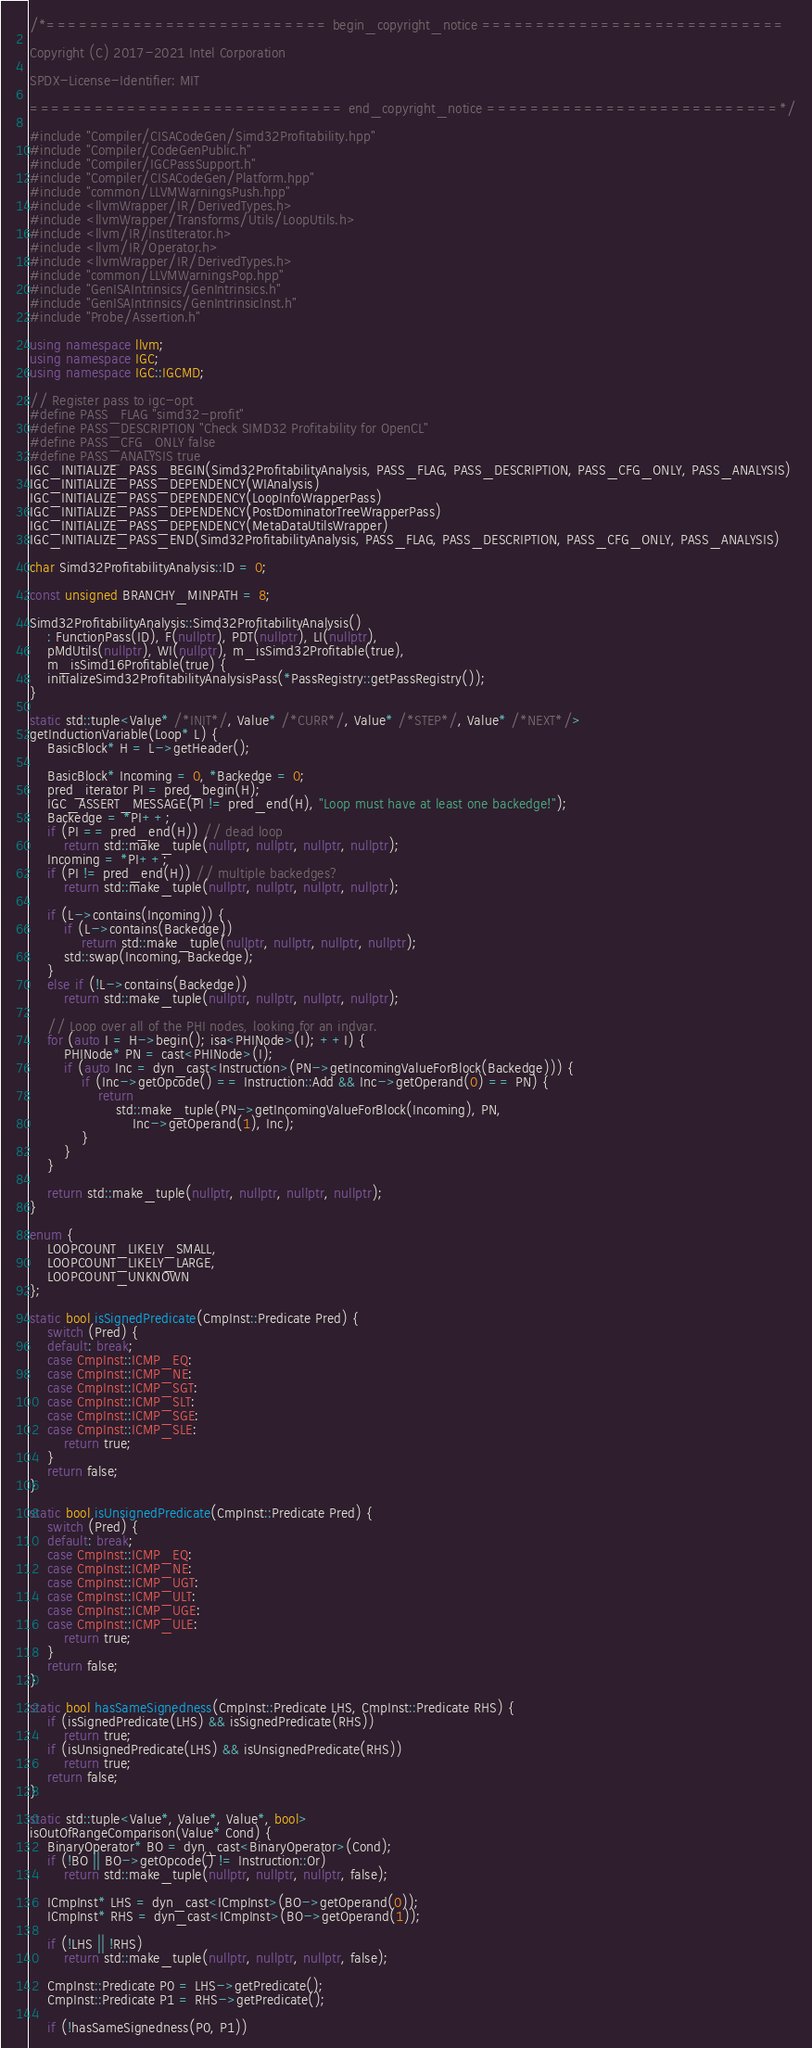Convert code to text. <code><loc_0><loc_0><loc_500><loc_500><_C++_>/*========================== begin_copyright_notice ============================

Copyright (C) 2017-2021 Intel Corporation

SPDX-License-Identifier: MIT

============================= end_copyright_notice ===========================*/

#include "Compiler/CISACodeGen/Simd32Profitability.hpp"
#include "Compiler/CodeGenPublic.h"
#include "Compiler/IGCPassSupport.h"
#include "Compiler/CISACodeGen/Platform.hpp"
#include "common/LLVMWarningsPush.hpp"
#include <llvmWrapper/IR/DerivedTypes.h>
#include <llvmWrapper/Transforms/Utils/LoopUtils.h>
#include <llvm/IR/InstIterator.h>
#include <llvm/IR/Operator.h>
#include <llvmWrapper/IR/DerivedTypes.h>
#include "common/LLVMWarningsPop.hpp"
#include "GenISAIntrinsics/GenIntrinsics.h"
#include "GenISAIntrinsics/GenIntrinsicInst.h"
#include "Probe/Assertion.h"

using namespace llvm;
using namespace IGC;
using namespace IGC::IGCMD;

// Register pass to igc-opt
#define PASS_FLAG "simd32-profit"
#define PASS_DESCRIPTION "Check SIMD32 Profitability for OpenCL"
#define PASS_CFG_ONLY false
#define PASS_ANALYSIS true
IGC_INITIALIZE_PASS_BEGIN(Simd32ProfitabilityAnalysis, PASS_FLAG, PASS_DESCRIPTION, PASS_CFG_ONLY, PASS_ANALYSIS)
IGC_INITIALIZE_PASS_DEPENDENCY(WIAnalysis)
IGC_INITIALIZE_PASS_DEPENDENCY(LoopInfoWrapperPass)
IGC_INITIALIZE_PASS_DEPENDENCY(PostDominatorTreeWrapperPass)
IGC_INITIALIZE_PASS_DEPENDENCY(MetaDataUtilsWrapper)
IGC_INITIALIZE_PASS_END(Simd32ProfitabilityAnalysis, PASS_FLAG, PASS_DESCRIPTION, PASS_CFG_ONLY, PASS_ANALYSIS)

char Simd32ProfitabilityAnalysis::ID = 0;

const unsigned BRANCHY_MINPATH = 8;

Simd32ProfitabilityAnalysis::Simd32ProfitabilityAnalysis()
    : FunctionPass(ID), F(nullptr), PDT(nullptr), LI(nullptr),
    pMdUtils(nullptr), WI(nullptr), m_isSimd32Profitable(true),
    m_isSimd16Profitable(true) {
    initializeSimd32ProfitabilityAnalysisPass(*PassRegistry::getPassRegistry());
}

static std::tuple<Value* /*INIT*/, Value* /*CURR*/, Value* /*STEP*/, Value* /*NEXT*/>
getInductionVariable(Loop* L) {
    BasicBlock* H = L->getHeader();

    BasicBlock* Incoming = 0, *Backedge = 0;
    pred_iterator PI = pred_begin(H);
    IGC_ASSERT_MESSAGE(PI != pred_end(H), "Loop must have at least one backedge!");
    Backedge = *PI++;
    if (PI == pred_end(H)) // dead loop
        return std::make_tuple(nullptr, nullptr, nullptr, nullptr);
    Incoming = *PI++;
    if (PI != pred_end(H)) // multiple backedges?
        return std::make_tuple(nullptr, nullptr, nullptr, nullptr);

    if (L->contains(Incoming)) {
        if (L->contains(Backedge))
            return std::make_tuple(nullptr, nullptr, nullptr, nullptr);
        std::swap(Incoming, Backedge);
    }
    else if (!L->contains(Backedge))
        return std::make_tuple(nullptr, nullptr, nullptr, nullptr);

    // Loop over all of the PHI nodes, looking for an indvar.
    for (auto I = H->begin(); isa<PHINode>(I); ++I) {
        PHINode* PN = cast<PHINode>(I);
        if (auto Inc = dyn_cast<Instruction>(PN->getIncomingValueForBlock(Backedge))) {
            if (Inc->getOpcode() == Instruction::Add && Inc->getOperand(0) == PN) {
                return
                    std::make_tuple(PN->getIncomingValueForBlock(Incoming), PN,
                        Inc->getOperand(1), Inc);
            }
        }
    }

    return std::make_tuple(nullptr, nullptr, nullptr, nullptr);
}

enum {
    LOOPCOUNT_LIKELY_SMALL,
    LOOPCOUNT_LIKELY_LARGE,
    LOOPCOUNT_UNKNOWN
};

static bool isSignedPredicate(CmpInst::Predicate Pred) {
    switch (Pred) {
    default: break;
    case CmpInst::ICMP_EQ:
    case CmpInst::ICMP_NE:
    case CmpInst::ICMP_SGT:
    case CmpInst::ICMP_SLT:
    case CmpInst::ICMP_SGE:
    case CmpInst::ICMP_SLE:
        return true;
    }
    return false;
}

static bool isUnsignedPredicate(CmpInst::Predicate Pred) {
    switch (Pred) {
    default: break;
    case CmpInst::ICMP_EQ:
    case CmpInst::ICMP_NE:
    case CmpInst::ICMP_UGT:
    case CmpInst::ICMP_ULT:
    case CmpInst::ICMP_UGE:
    case CmpInst::ICMP_ULE:
        return true;
    }
    return false;
}

static bool hasSameSignedness(CmpInst::Predicate LHS, CmpInst::Predicate RHS) {
    if (isSignedPredicate(LHS) && isSignedPredicate(RHS))
        return true;
    if (isUnsignedPredicate(LHS) && isUnsignedPredicate(RHS))
        return true;
    return false;
}

static std::tuple<Value*, Value*, Value*, bool>
isOutOfRangeComparison(Value* Cond) {
    BinaryOperator* BO = dyn_cast<BinaryOperator>(Cond);
    if (!BO || BO->getOpcode() != Instruction::Or)
        return std::make_tuple(nullptr, nullptr, nullptr, false);

    ICmpInst* LHS = dyn_cast<ICmpInst>(BO->getOperand(0));
    ICmpInst* RHS = dyn_cast<ICmpInst>(BO->getOperand(1));

    if (!LHS || !RHS)
        return std::make_tuple(nullptr, nullptr, nullptr, false);

    CmpInst::Predicate P0 = LHS->getPredicate();
    CmpInst::Predicate P1 = RHS->getPredicate();

    if (!hasSameSignedness(P0, P1))</code> 